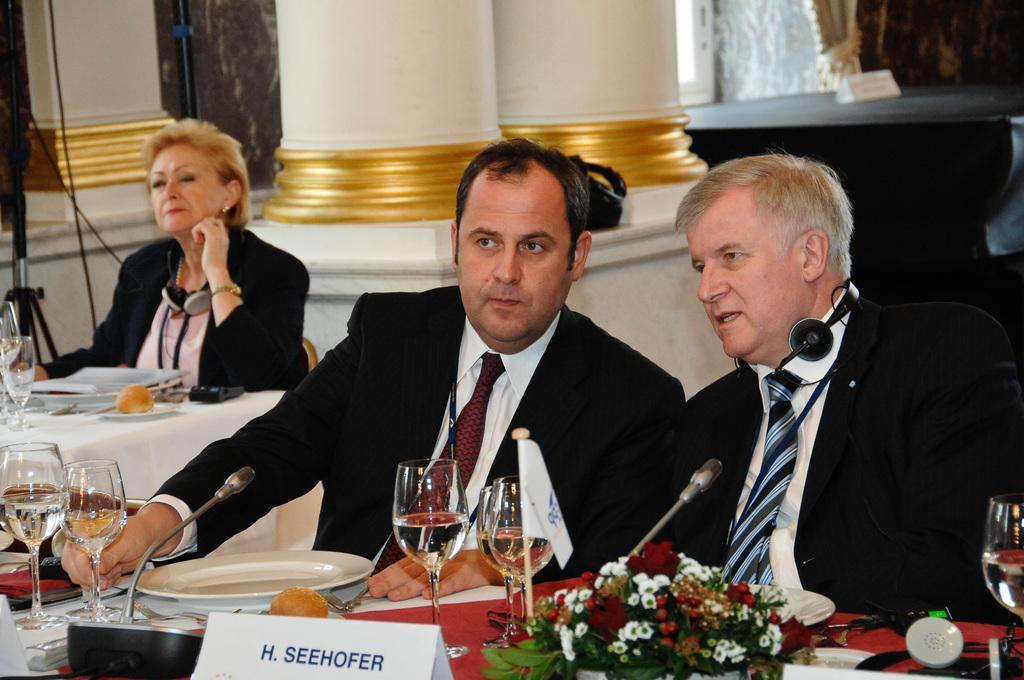In one or two sentences, can you explain what this image depicts? In the image there are persons in suits sitting in front of table talking, there are wine glasses,plates,flower vase on the table, on the left side there is a woman sitting in front of table, behind here there are pillars. 